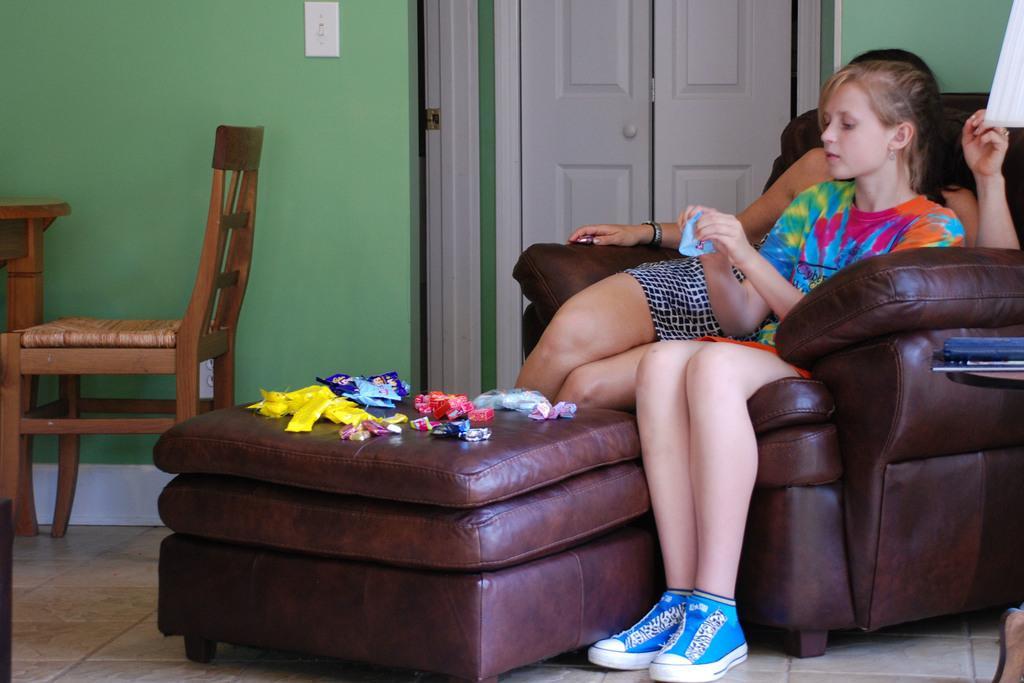Can you describe this image briefly? In the image we can see two persons were siting on the chair. In front there is a table,on table we can see chocolates and packets. In the background there is a wall,door,chair and table. 